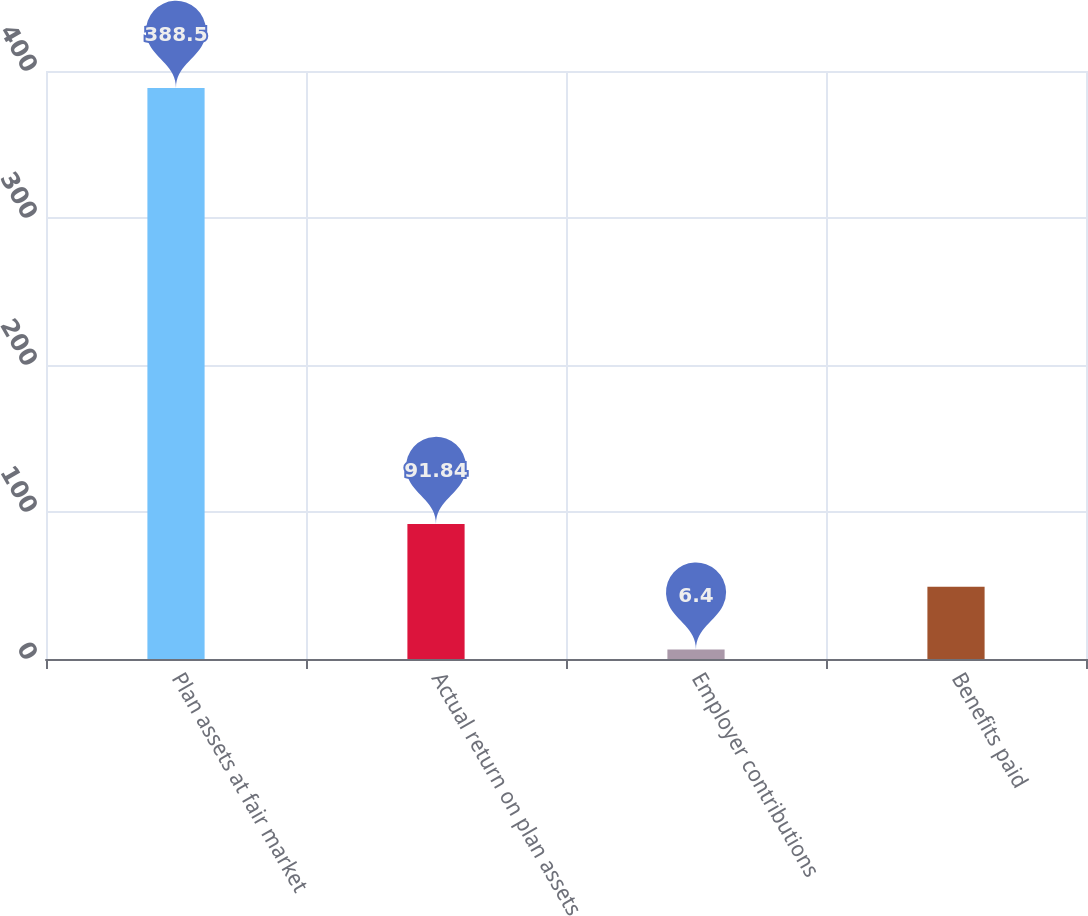<chart> <loc_0><loc_0><loc_500><loc_500><bar_chart><fcel>Plan assets at fair market<fcel>Actual return on plan assets<fcel>Employer contributions<fcel>Benefits paid<nl><fcel>388.5<fcel>91.84<fcel>6.4<fcel>49.12<nl></chart> 